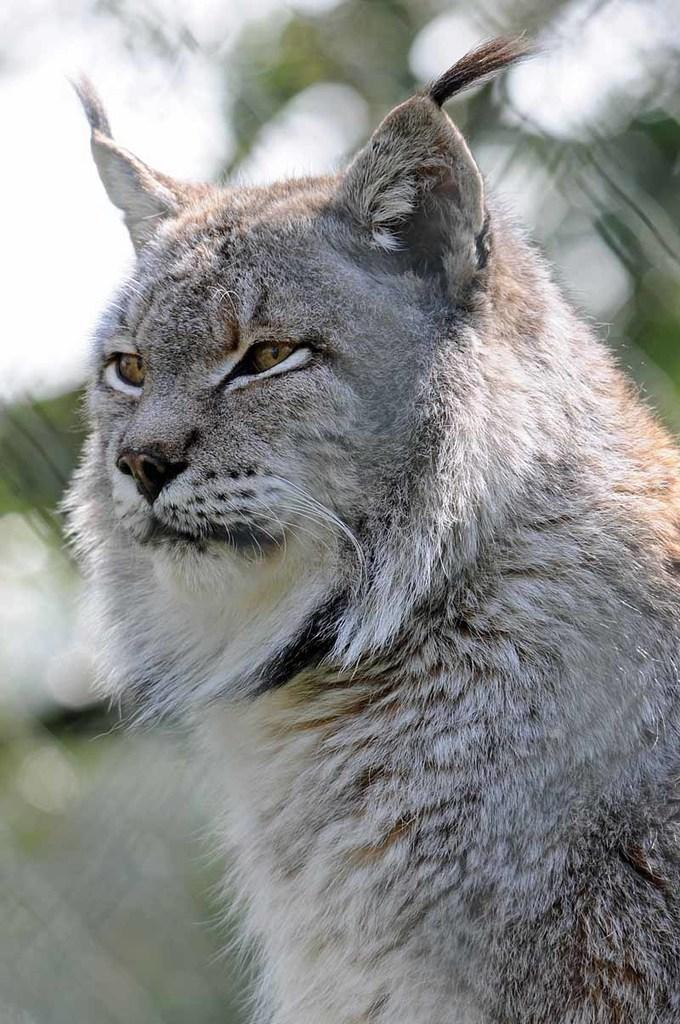What type of animal can be seen in the background of the image? There is a cat in the background of the image. How clear is the image of the cat? The cat is blurred in the image. What type of salt is being used to defuse the bomb in the image? There is no salt or bomb present in the image; it only features a blurred cat in the background. 